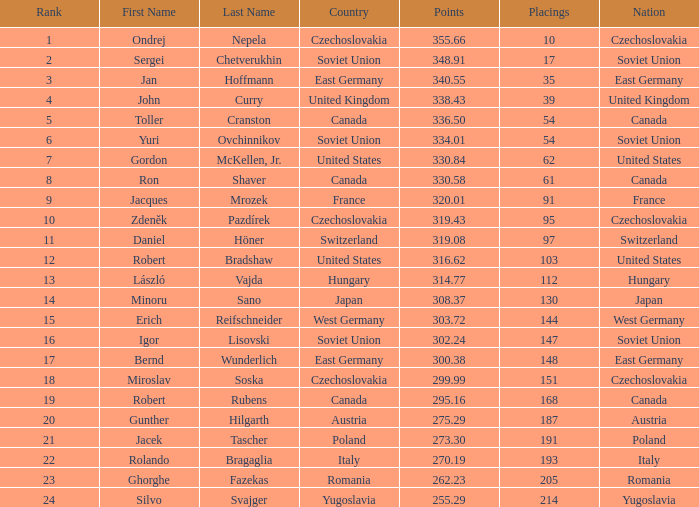43? None. 